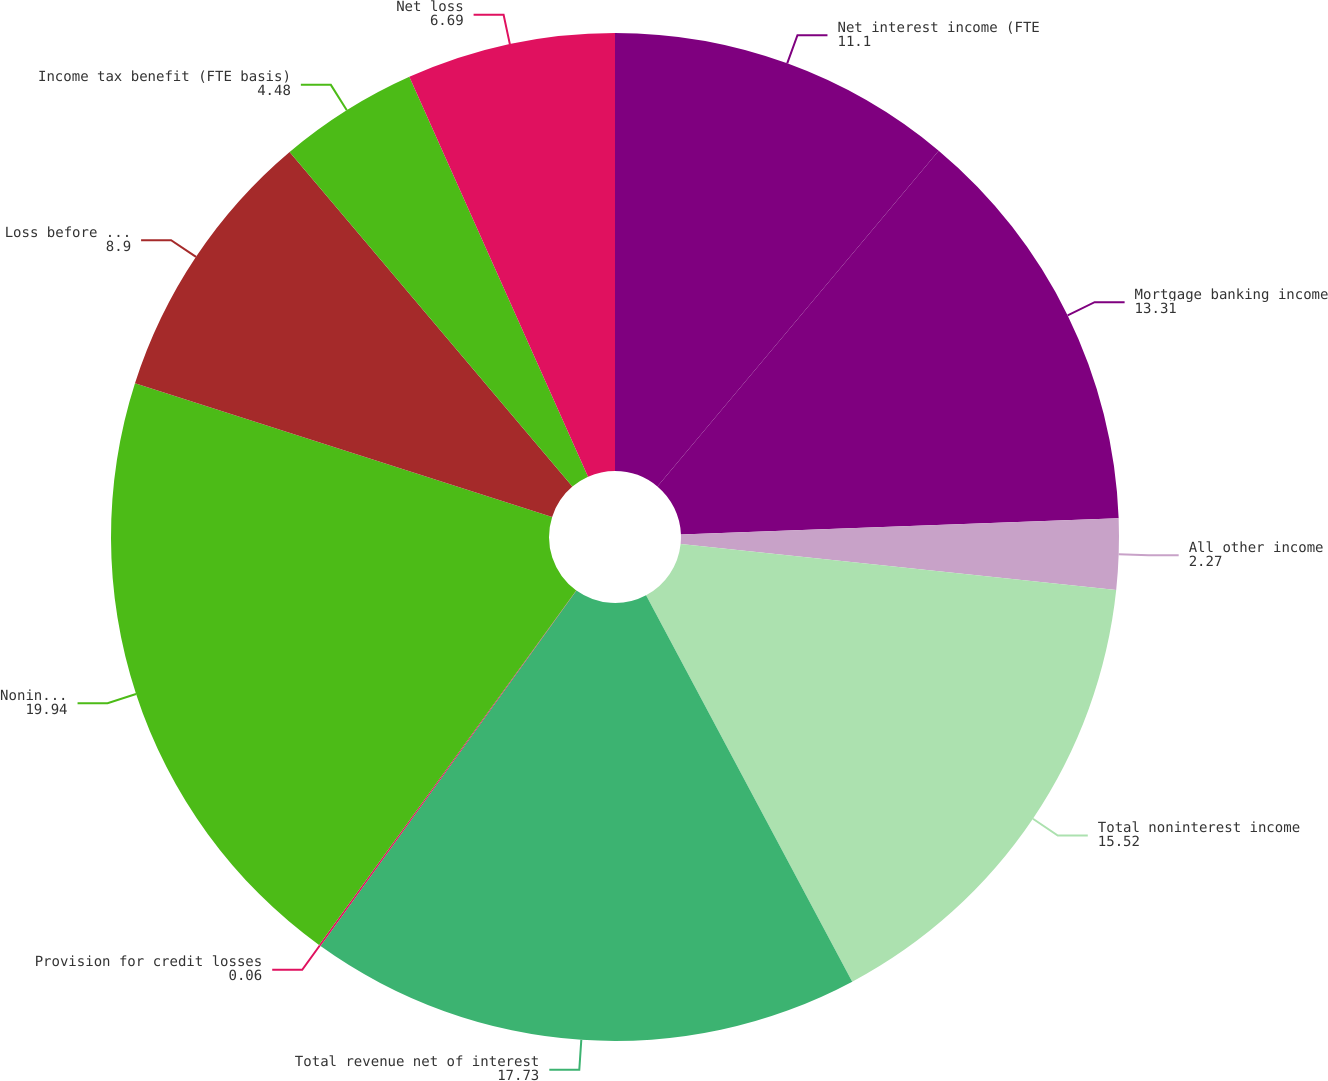<chart> <loc_0><loc_0><loc_500><loc_500><pie_chart><fcel>Net interest income (FTE<fcel>Mortgage banking income<fcel>All other income<fcel>Total noninterest income<fcel>Total revenue net of interest<fcel>Provision for credit losses<fcel>Noninterest expense<fcel>Loss before income taxes (FTE<fcel>Income tax benefit (FTE basis)<fcel>Net loss<nl><fcel>11.1%<fcel>13.31%<fcel>2.27%<fcel>15.52%<fcel>17.73%<fcel>0.06%<fcel>19.94%<fcel>8.9%<fcel>4.48%<fcel>6.69%<nl></chart> 